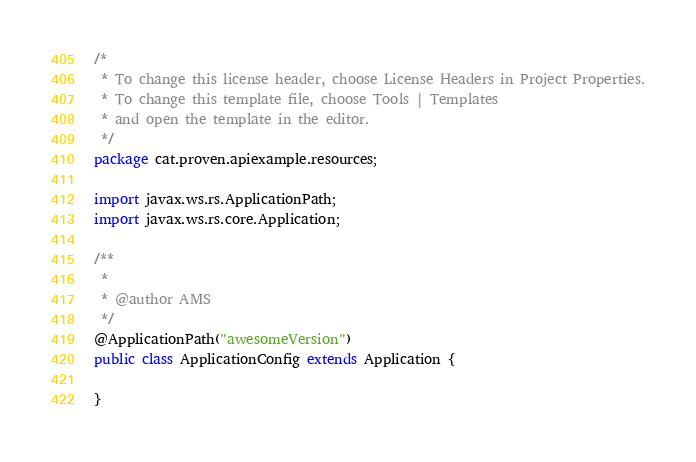Convert code to text. <code><loc_0><loc_0><loc_500><loc_500><_Java_>/*
 * To change this license header, choose License Headers in Project Properties.
 * To change this template file, choose Tools | Templates
 * and open the template in the editor.
 */
package cat.proven.apiexample.resources;

import javax.ws.rs.ApplicationPath;
import javax.ws.rs.core.Application;

/**
 *
 * @author AMS
 */
@ApplicationPath("awesomeVersion")
public class ApplicationConfig extends Application {
    
}
</code> 